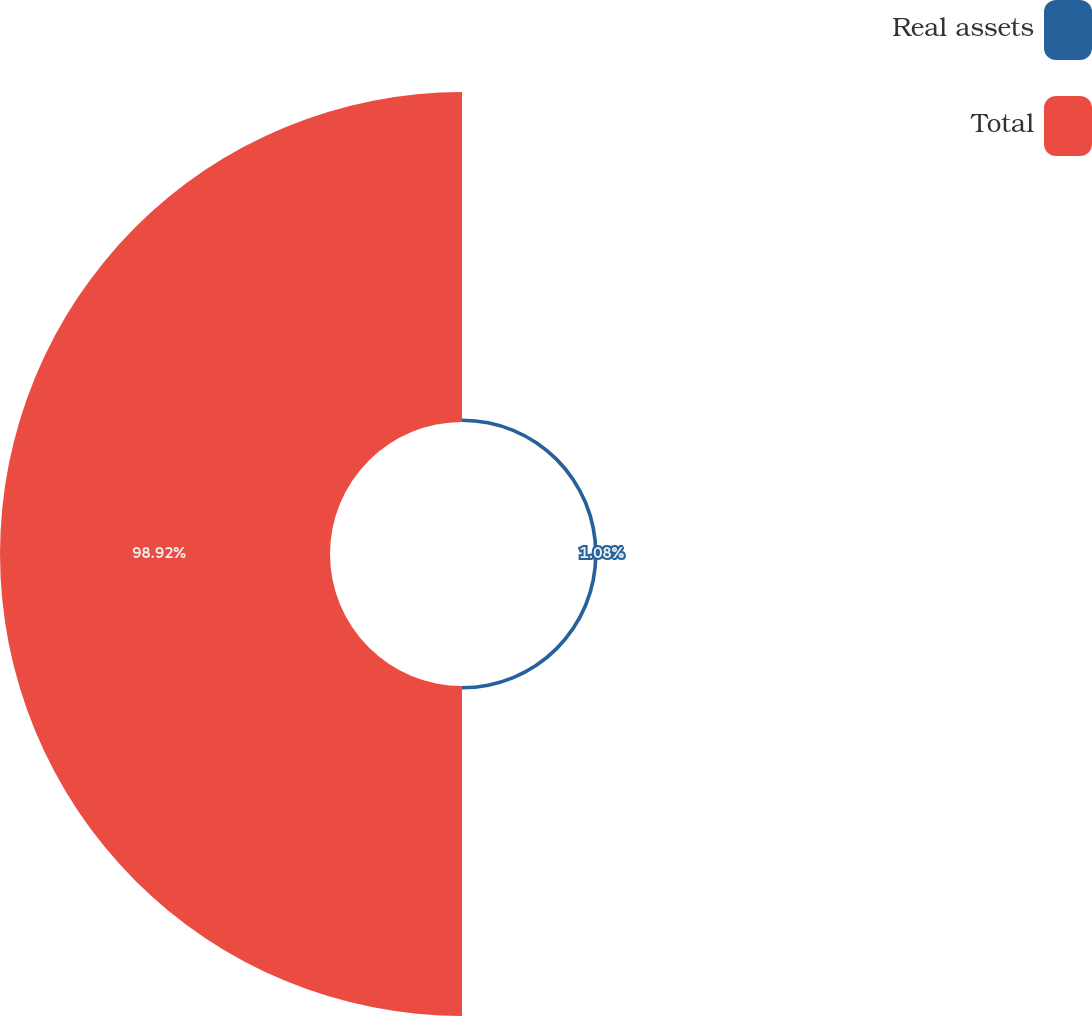<chart> <loc_0><loc_0><loc_500><loc_500><pie_chart><fcel>Real assets<fcel>Total<nl><fcel>1.08%<fcel>98.92%<nl></chart> 